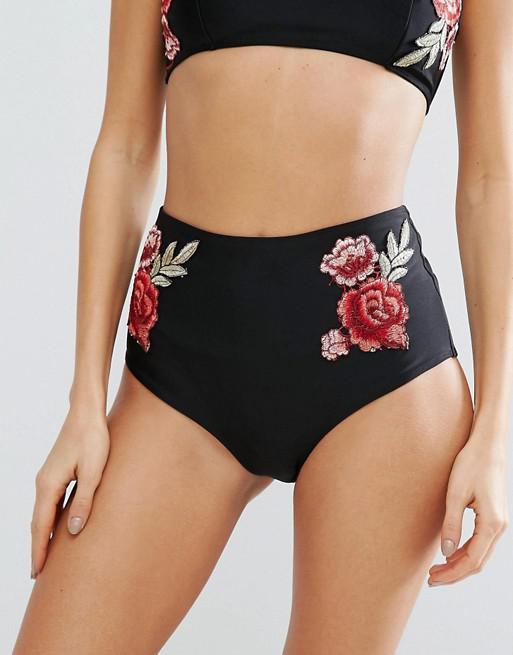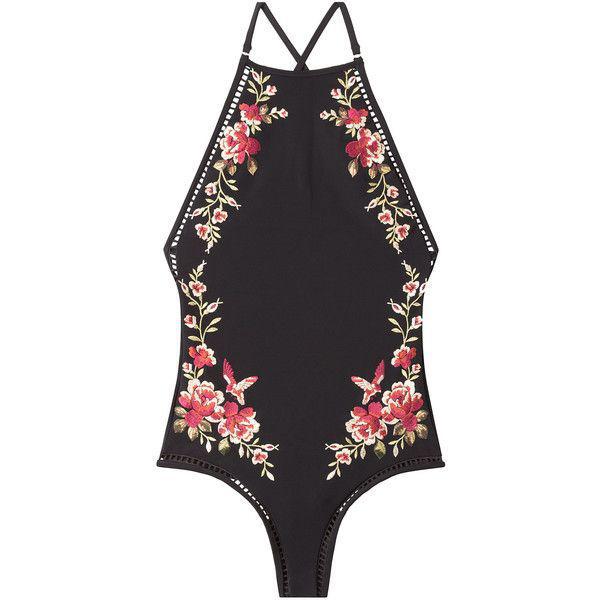The first image is the image on the left, the second image is the image on the right. For the images displayed, is the sentence "the bathing suit in one of the images features a tie on bikini top." factually correct? Answer yes or no. No. 